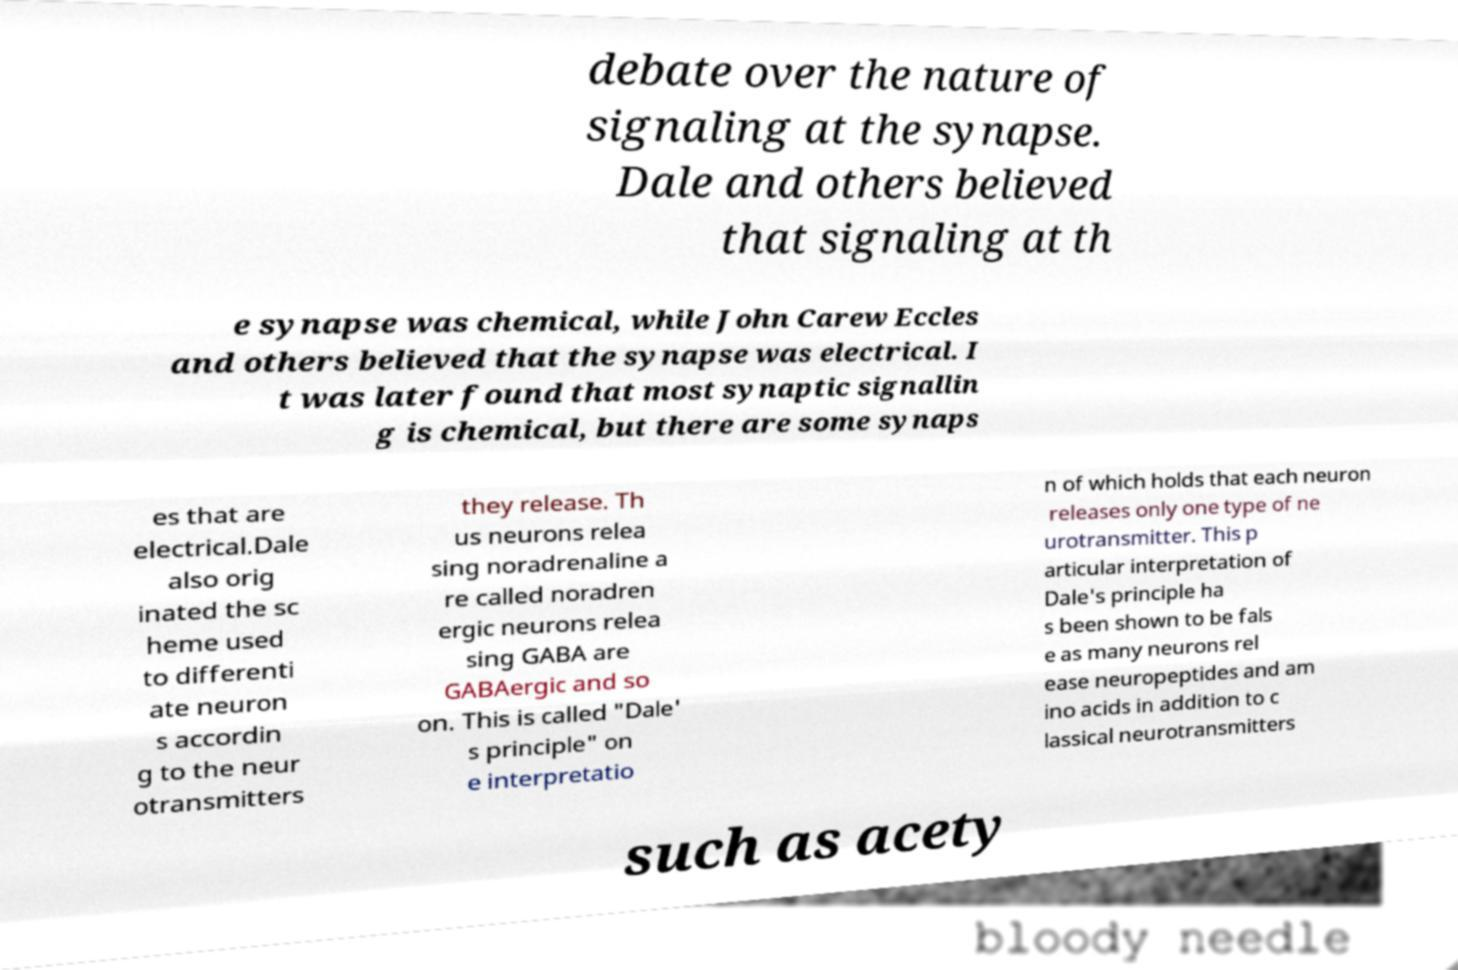What messages or text are displayed in this image? I need them in a readable, typed format. debate over the nature of signaling at the synapse. Dale and others believed that signaling at th e synapse was chemical, while John Carew Eccles and others believed that the synapse was electrical. I t was later found that most synaptic signallin g is chemical, but there are some synaps es that are electrical.Dale also orig inated the sc heme used to differenti ate neuron s accordin g to the neur otransmitters they release. Th us neurons relea sing noradrenaline a re called noradren ergic neurons relea sing GABA are GABAergic and so on. This is called "Dale' s principle" on e interpretatio n of which holds that each neuron releases only one type of ne urotransmitter. This p articular interpretation of Dale's principle ha s been shown to be fals e as many neurons rel ease neuropeptides and am ino acids in addition to c lassical neurotransmitters such as acety 